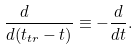Convert formula to latex. <formula><loc_0><loc_0><loc_500><loc_500>\frac { d \quad } { d ( t _ { t r } - t ) } \equiv - \frac { d } { d t } .</formula> 